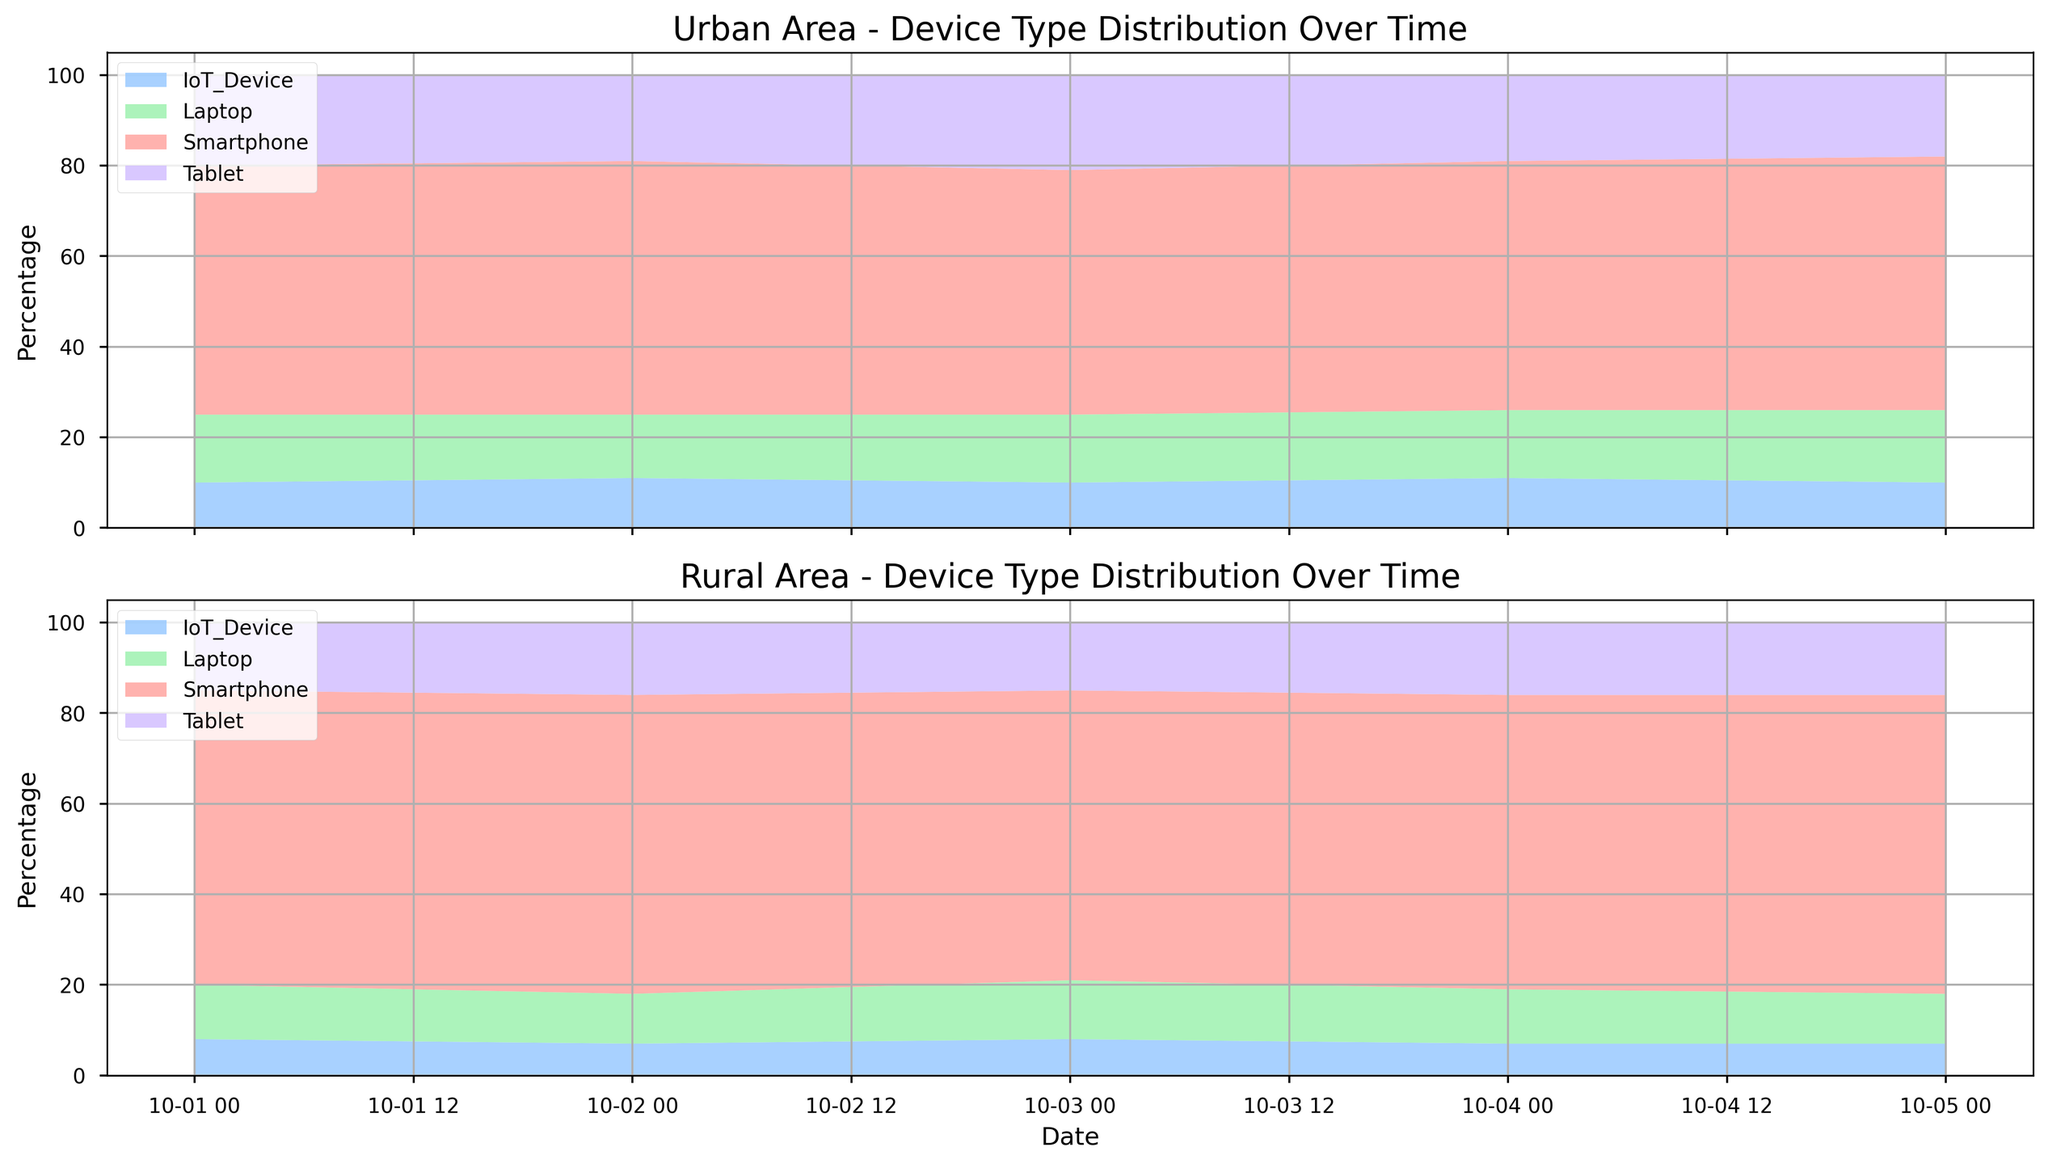Which area has a higher percentage of Smartphone traffic on 2023-10-01? On 2023-10-01, the Smartphone traffic percentage is 55% in urban areas and 65% in rural areas. Hence, rural areas have a higher percentage.
Answer: Rural Between Urban and Rural areas, which device type shows the most consistent percentage over time? Over the given dates (2023-10-01 to 2023-10-05), the Tablet percentage in Urban areas varies between 18% and 21%, and in Rural areas between 15% and 16%. Comparing the ranges, Rural Tablets have the smallest range of variation (1%), indicating more consistency.
Answer: Tablet in Rural areas What is the total percentage of IoT_Device traffic in Urban areas over the five days? Summing up the percentages for IoT_Device in Urban areas: 10% + 11% + 10% + 11% + 10% = 52%. The total percentage is 52%.
Answer: 52 Which device type had the highest percentage on 2023-10-05 in Urban areas? Looking at the percentages for Urban areas on 2023-10-05, Smartphones (56%) have the highest share.
Answer: Smartphone Does the percentage of Laptops in Rural areas ever surpass Urban areas? If so, when? On 2023-10-03, Laptops in Rural areas have a percentage of 13%, while Urban areas have 15%. On all other dates, Urban areas have a higher or equal percentage. Hence, there is no day where Rural surpasses Urban.
Answer: No What is the average percentage of Tablet usage in Rural areas? The Tablet percentages for Rural areas on the 5 days are: 15%, 16%, 15%, 16%, 16%. Adding these and dividing by 5, the average is (15 + 16 + 15 + 16 + 16) / 5 = 15.6%.
Answer: 15.6 Compare the change in percentage of Smartphone traffic between Urban and Rural areas from 2023-10-01 to 2023-10-02. In Urban areas, Smartphone traffic changes from 55% to 56%, an increase of 1%. In Rural areas, it changes from 65% to 66%, also an increase of 1%. Both areas have the same change.
Answer: Same change (1%) Is there a device type for which Urban areas have a higher or equal percentage than Rural areas on all given days? By comparing all device types for given days, Smartphones do not meet the criteria (Urban is always lower/equal except 2023-10-01). Tablets, Laptops, and IoT_Device must be verified. Referencing them all point by point, Tablets and Laptops always have equal percentages at least once, fulfilling the condition.
Answer: Tablets & Laptops Which date shows the smallest gap in IoT_Device traffic between Urban and Rural areas? Subtracting IoT_Device percentages on each date between areas gives 2023-10-01: 10-8=2, 2023-10-02: 11-7=4, 2023-10-03: 10-8=2, 2023-10-04: 11-7=4, 2023-10-05: 10-7=3. The smallest gap, 2%, occurs on 2023-10-01 and 2023-10-03.
Answer: 2023-10-01 and 2023-10-03 What is the trend of Laptop usage in Urban areas from 2023-10-01 to 2023-10-05? The Laptop percentages in Urban areas over the days are: 15% (01), 14% (02), 15% (03), 15% (04), and 16% (05). There is a slight dip on 2023-10-02, but overall, it follows an increasing trend.
Answer: Slightly increasing 